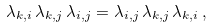<formula> <loc_0><loc_0><loc_500><loc_500>\lambda _ { k , i } \, \lambda _ { k , j } \, \lambda _ { i , j } = \lambda _ { i , j } \, \lambda _ { k , j } \, \lambda _ { k , i } \, ,</formula> 